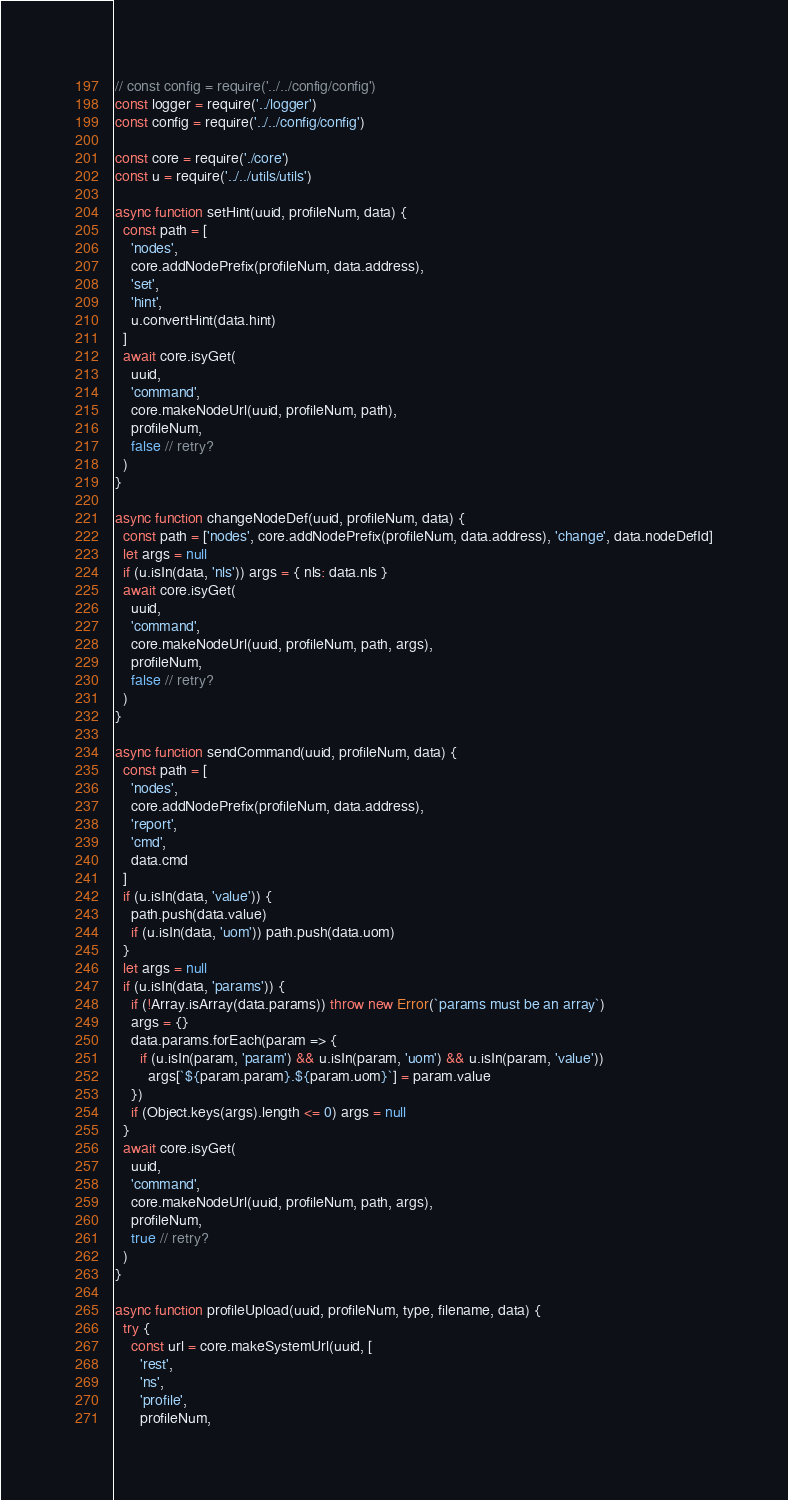Convert code to text. <code><loc_0><loc_0><loc_500><loc_500><_JavaScript_>// const config = require('../../config/config')
const logger = require('../logger')
const config = require('../../config/config')

const core = require('./core')
const u = require('../../utils/utils')

async function setHint(uuid, profileNum, data) {
  const path = [
    'nodes',
    core.addNodePrefix(profileNum, data.address),
    'set',
    'hint',
    u.convertHint(data.hint)
  ]
  await core.isyGet(
    uuid,
    'command',
    core.makeNodeUrl(uuid, profileNum, path),
    profileNum,
    false // retry?
  )
}

async function changeNodeDef(uuid, profileNum, data) {
  const path = ['nodes', core.addNodePrefix(profileNum, data.address), 'change', data.nodeDefId]
  let args = null
  if (u.isIn(data, 'nls')) args = { nls: data.nls }
  await core.isyGet(
    uuid,
    'command',
    core.makeNodeUrl(uuid, profileNum, path, args),
    profileNum,
    false // retry?
  )
}

async function sendCommand(uuid, profileNum, data) {
  const path = [
    'nodes',
    core.addNodePrefix(profileNum, data.address),
    'report',
    'cmd',
    data.cmd
  ]
  if (u.isIn(data, 'value')) {
    path.push(data.value)
    if (u.isIn(data, 'uom')) path.push(data.uom)
  }
  let args = null
  if (u.isIn(data, 'params')) {
    if (!Array.isArray(data.params)) throw new Error(`params must be an array`)
    args = {}
    data.params.forEach(param => {
      if (u.isIn(param, 'param') && u.isIn(param, 'uom') && u.isIn(param, 'value'))
        args[`${param.param}.${param.uom}`] = param.value
    })
    if (Object.keys(args).length <= 0) args = null
  }
  await core.isyGet(
    uuid,
    'command',
    core.makeNodeUrl(uuid, profileNum, path, args),
    profileNum,
    true // retry?
  )
}

async function profileUpload(uuid, profileNum, type, filename, data) {
  try {
    const url = core.makeSystemUrl(uuid, [
      'rest',
      'ns',
      'profile',
      profileNum,</code> 